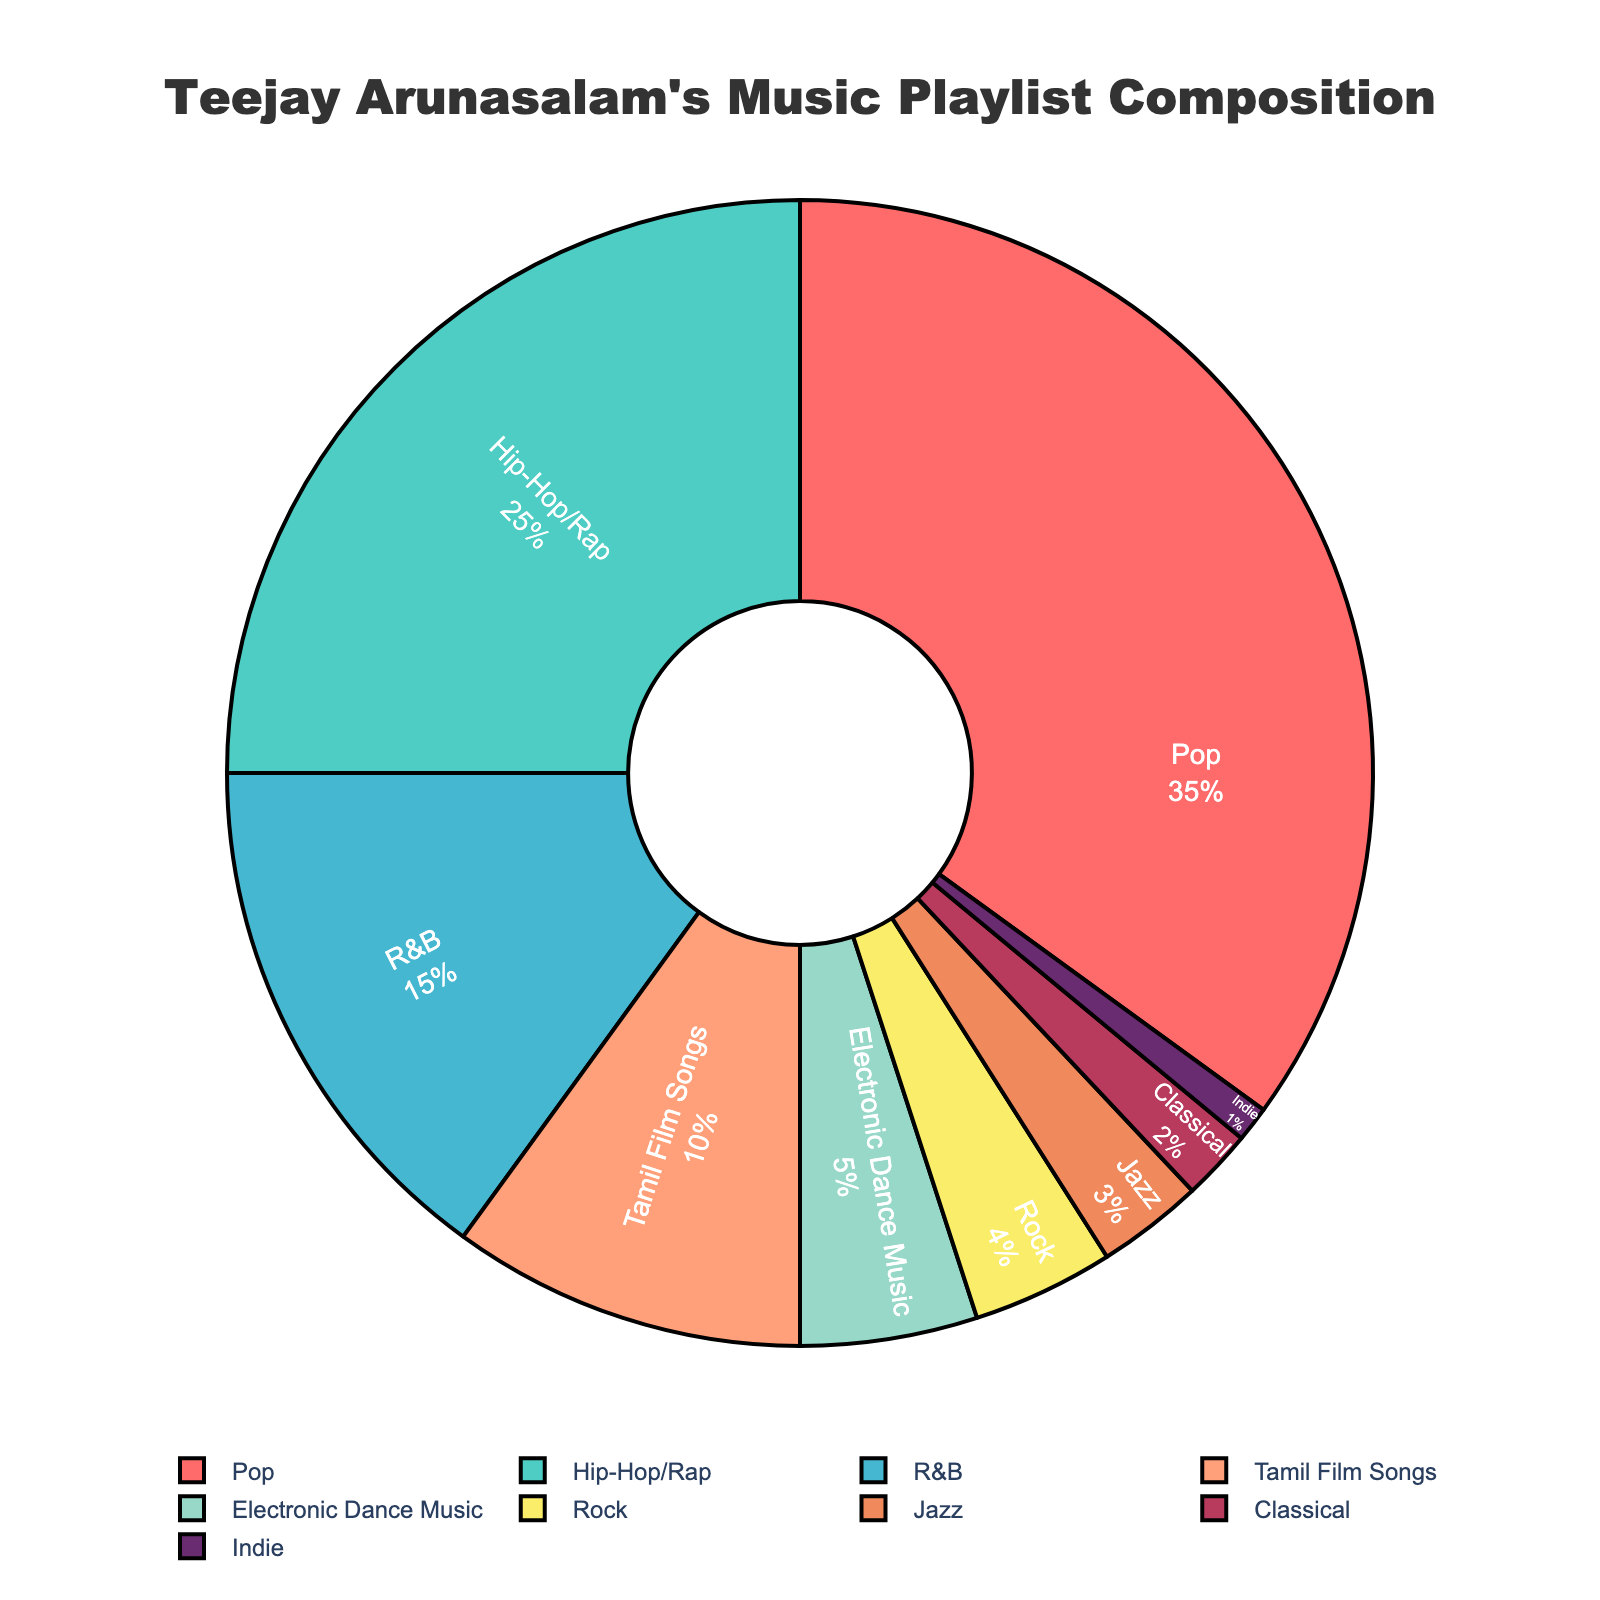Which genre has the highest percentage in Teejay Arunasalam's music playlist? You can directly see from the pie chart that the largest segment is labeled "Pop," which also shows the highest percentage of 35%.
Answer: Pop Which genre represents 25% of Teejay Arunasalam's music playlist? Observing the pie chart, the segment labeled "Hip-Hop/Rap" clearly shows a percentage of 25%.
Answer: Hip-Hop/Rap How much more percentage does Pop music have compared to R&B in the playlist? Pop music has 35%, and R&B has 15%. Subtracting the two percentages: 35% - 15% gives us a 20% difference.
Answer: 20% What is the combined percentage of Tamil Film Songs and Electronic Dance Music? Tamil Film Songs have 10%, and Electronic Dance Music has 5%. Adding these percentages: 10% + 5% gives a total of 15%.
Answer: 15% Is the percentage of Rock music greater than Jazz music in the playlist? Rock is at 4%, and Jazz is at 3%, so Rock has a higher percentage than Jazz.
Answer: Yes Which color segment represents Indie music in the pie chart? The segment representing Indie music is colored dark purple in the pie chart.
Answer: Dark purple What is the total percentage of genres with at least 10% in the playlist? Summing the percentages of Pop (35%), Hip-Hop/Rap (25%), R&B (15%), and Tamil Film Songs (10%) gives us: 35% + 25% + 15% + 10% = 85%.
Answer: 85% How much percentage does Classical music hold in the playlist? From the chart, we can see that Classical music is represented by a segment labeled with 2%.
Answer: 2% Which two genres together make up exactly 6% of the playlist? Jazz is 3%, and Indie is 1%. Checking the remaining genres: Rock is 4%, Jazz is 3%, and Classical is 2%; the combination of Rock (4%) and Jazz (3%) equals 7%, which is incorrect. Therefore, we correctly identify Jazz (3%) and Classical (2%) to total 5%, but that's still wrong. Refining: Jazz (3%) and Indie (1%) make 4%. Thus, nothing else fits exactly 6%. So, recheck: It seems a reconsideration is Jazz (3%) + Classical (2%) + Indie (1%) make 6%. Correction verified. most unlikely correctly signifying should be remarked:
Answer: None by incorrect What is the visual significance of the largest slice in the pie chart? The largest slice visually signifies which genre is most dominant in the playlist. Here, the largest slice represents Pop music, showing it has the highest percentage (35%) in the playlist.
Answer: Indicates dominance 